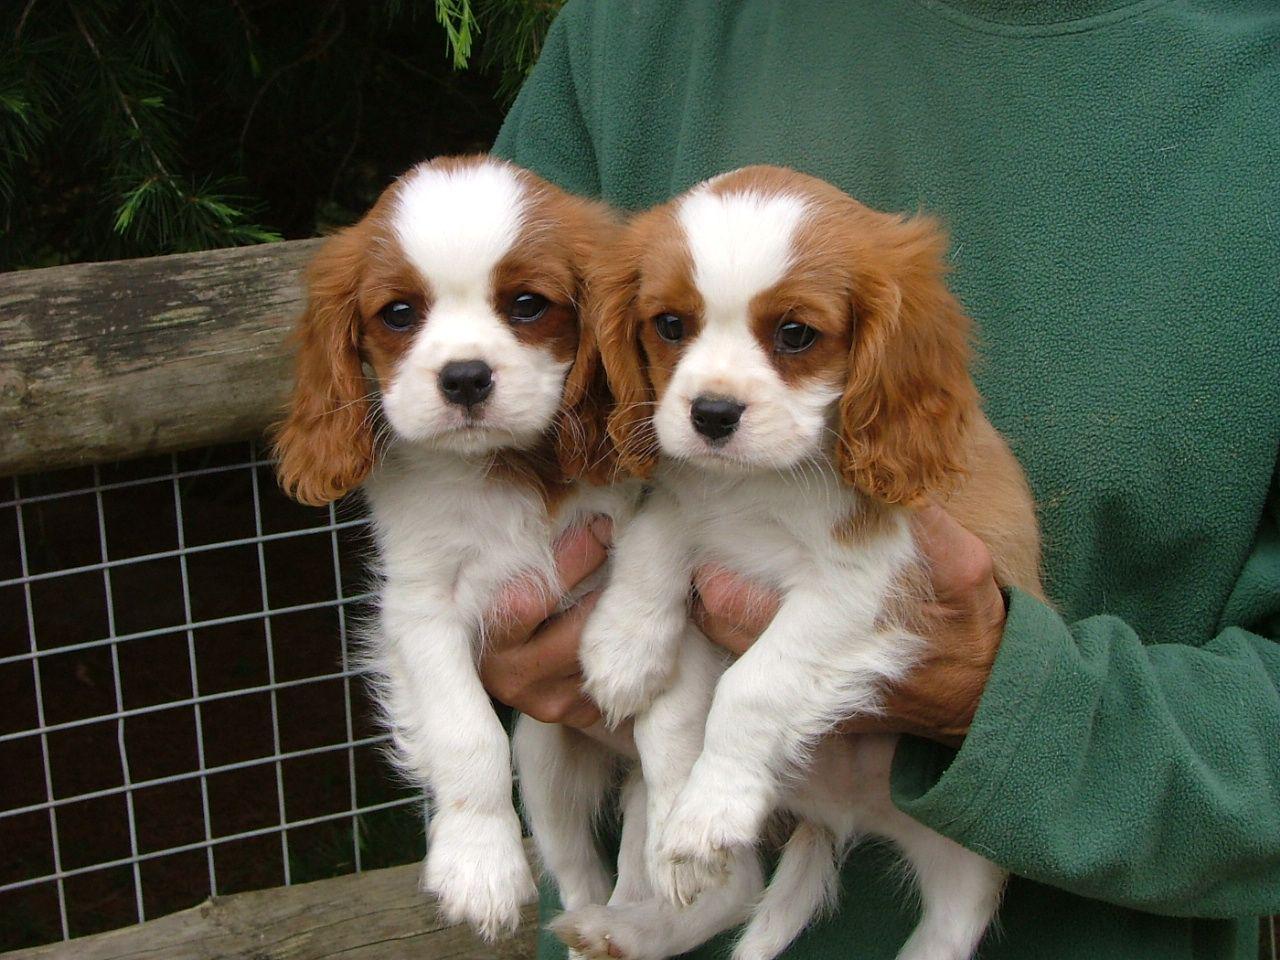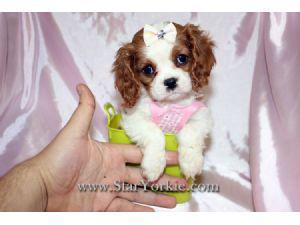The first image is the image on the left, the second image is the image on the right. For the images displayed, is the sentence "The right image shows a small brown and white dog with a bow on its head" factually correct? Answer yes or no. Yes. The first image is the image on the left, the second image is the image on the right. For the images shown, is this caption "A person is holding up two dogs in the image on the left." true? Answer yes or no. Yes. 